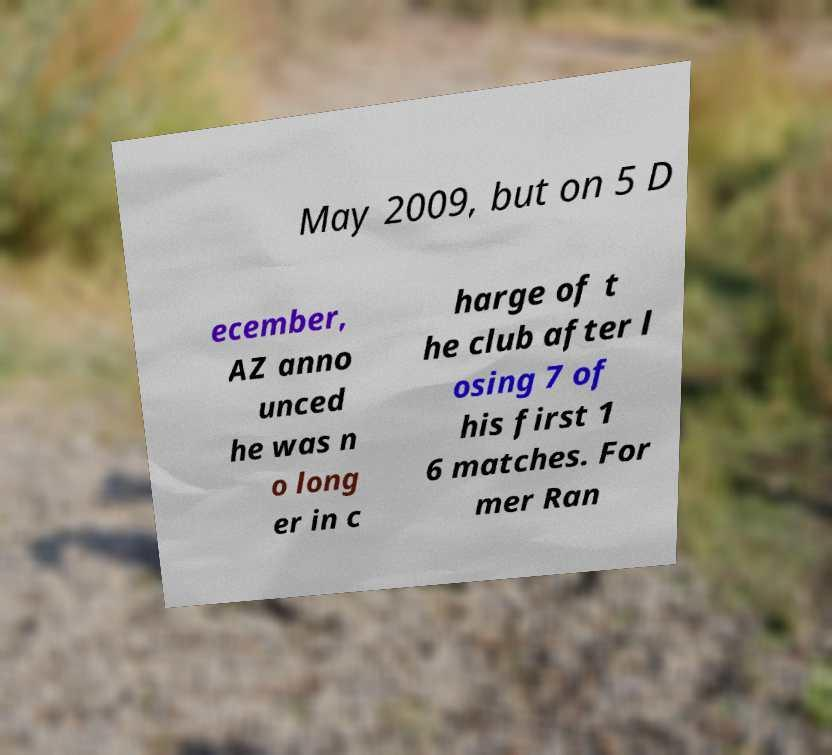Please read and relay the text visible in this image. What does it say? May 2009, but on 5 D ecember, AZ anno unced he was n o long er in c harge of t he club after l osing 7 of his first 1 6 matches. For mer Ran 